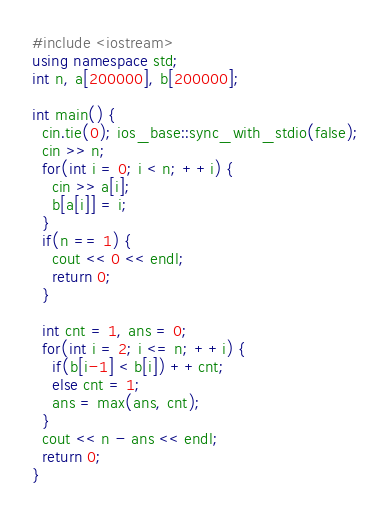<code> <loc_0><loc_0><loc_500><loc_500><_C++_>#include <iostream>
using namespace std;
int n, a[200000], b[200000];

int main() {
  cin.tie(0); ios_base::sync_with_stdio(false);
  cin >> n;
  for(int i = 0; i < n; ++i) {
    cin >> a[i];
    b[a[i]] = i;
  }
  if(n == 1) {
    cout << 0 << endl;
    return 0;
  }

  int cnt = 1, ans = 0;
  for(int i = 2; i <= n; ++i) {
    if(b[i-1] < b[i]) ++cnt;
    else cnt = 1;
    ans = max(ans, cnt);
  }
  cout << n - ans << endl;
  return 0;
}</code> 